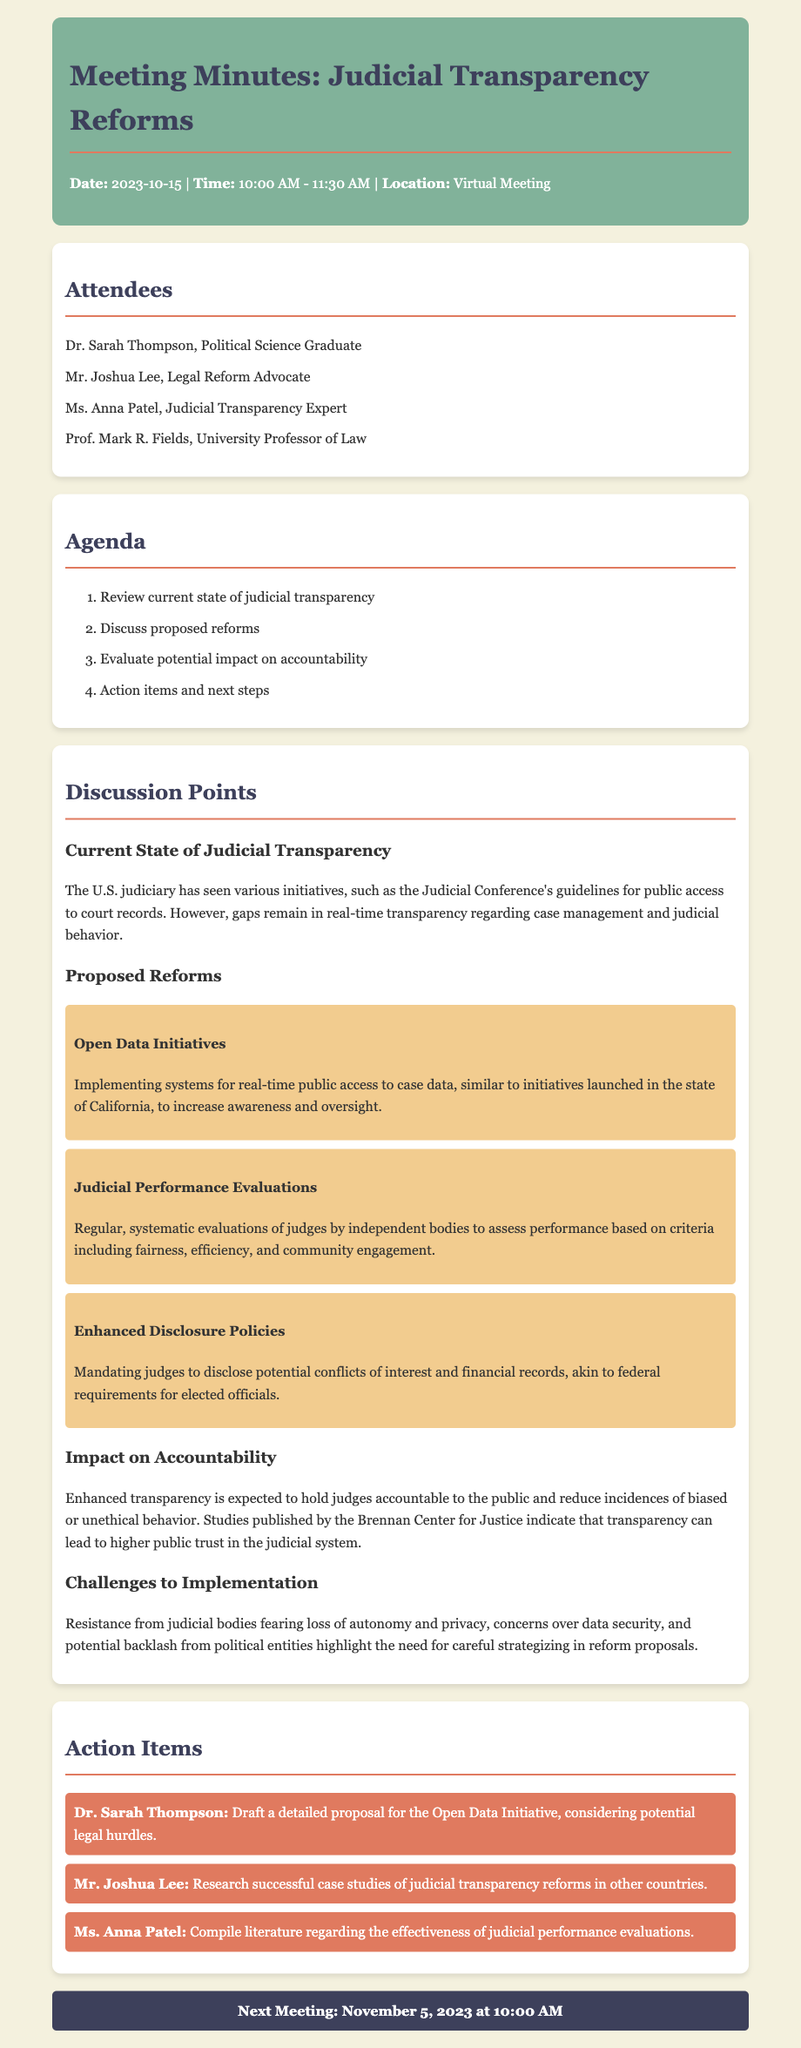What is the date of the meeting? The date of the meeting is listed in the header section of the document.
Answer: 2023-10-15 Who is the judicial transparency expert present? This information is found in the attendees list, which includes the names and titles of participants.
Answer: Ms. Anna Patel What is one of the proposed reforms discussed? The proposed reforms are detailed in the discussion points section and include multiple initiatives.
Answer: Open Data Initiatives What is the primary benefit of enhanced transparency mentioned? The discussion points outline the expected impact of reforms on accountability and public trust.
Answer: Higher public trust Who is responsible for researching successful case studies? The action items section specifies who will undertake each task, relating them to the proposed reforms.
Answer: Mr. Joshua Lee 